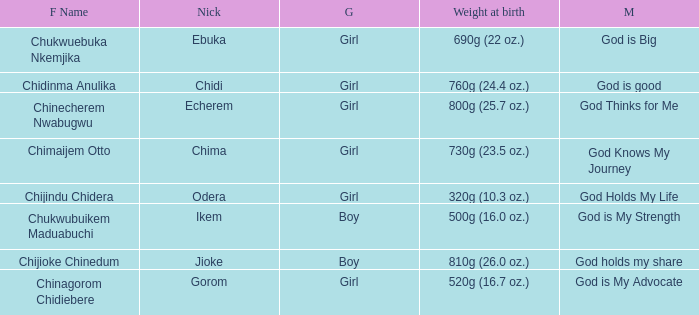Chukwubuikem Maduabuchi is what gender? Boy. Help me parse the entirety of this table. {'header': ['F Name', 'Nick', 'G', 'Weight at birth', 'M'], 'rows': [['Chukwuebuka Nkemjika', 'Ebuka', 'Girl', '690g (22 oz.)', 'God is Big'], ['Chidinma Anulika', 'Chidi', 'Girl', '760g (24.4 oz.)', 'God is good'], ['Chinecherem Nwabugwu', 'Echerem', 'Girl', '800g (25.7 oz.)', 'God Thinks for Me'], ['Chimaijem Otto', 'Chima', 'Girl', '730g (23.5 oz.)', 'God Knows My Journey'], ['Chijindu Chidera', 'Odera', 'Girl', '320g (10.3 oz.)', 'God Holds My Life'], ['Chukwubuikem Maduabuchi', 'Ikem', 'Boy', '500g (16.0 oz.)', 'God is My Strength'], ['Chijioke Chinedum', 'Jioke', 'Boy', '810g (26.0 oz.)', 'God holds my share'], ['Chinagorom Chidiebere', 'Gorom', 'Girl', '520g (16.7 oz.)', 'God is My Advocate']]} 